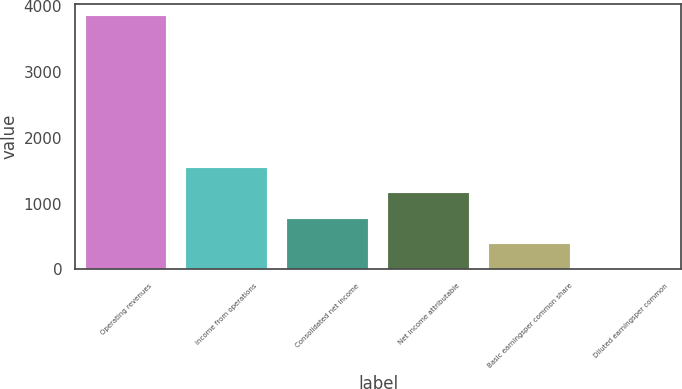<chart> <loc_0><loc_0><loc_500><loc_500><bar_chart><fcel>Operating revenues<fcel>Income from operations<fcel>Consolidated net income<fcel>Net income attributable<fcel>Basic earningsper common share<fcel>Diluted earningsper common<nl><fcel>3842<fcel>1537.56<fcel>769.4<fcel>1153.48<fcel>385.32<fcel>1.24<nl></chart> 